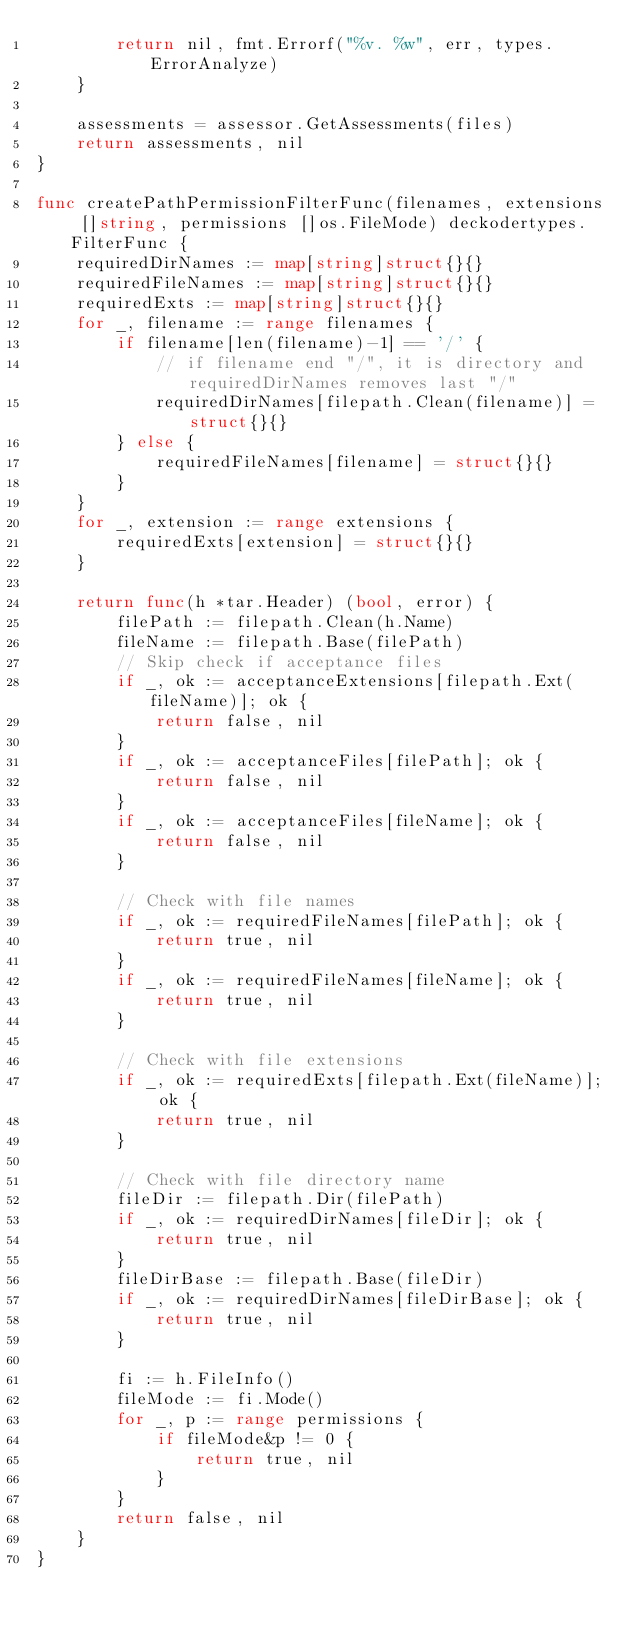Convert code to text. <code><loc_0><loc_0><loc_500><loc_500><_Go_>		return nil, fmt.Errorf("%v. %w", err, types.ErrorAnalyze)
	}

	assessments = assessor.GetAssessments(files)
	return assessments, nil
}

func createPathPermissionFilterFunc(filenames, extensions []string, permissions []os.FileMode) deckodertypes.FilterFunc {
	requiredDirNames := map[string]struct{}{}
	requiredFileNames := map[string]struct{}{}
	requiredExts := map[string]struct{}{}
	for _, filename := range filenames {
		if filename[len(filename)-1] == '/' {
			// if filename end "/", it is directory and requiredDirNames removes last "/"
			requiredDirNames[filepath.Clean(filename)] = struct{}{}
		} else {
			requiredFileNames[filename] = struct{}{}
		}
	}
	for _, extension := range extensions {
		requiredExts[extension] = struct{}{}
	}

	return func(h *tar.Header) (bool, error) {
		filePath := filepath.Clean(h.Name)
		fileName := filepath.Base(filePath)
		// Skip check if acceptance files
		if _, ok := acceptanceExtensions[filepath.Ext(fileName)]; ok {
			return false, nil
		}
		if _, ok := acceptanceFiles[filePath]; ok {
			return false, nil
		}
		if _, ok := acceptanceFiles[fileName]; ok {
			return false, nil
		}

		// Check with file names
		if _, ok := requiredFileNames[filePath]; ok {
			return true, nil
		}
		if _, ok := requiredFileNames[fileName]; ok {
			return true, nil
		}

		// Check with file extensions
		if _, ok := requiredExts[filepath.Ext(fileName)]; ok {
			return true, nil
		}

		// Check with file directory name
		fileDir := filepath.Dir(filePath)
		if _, ok := requiredDirNames[fileDir]; ok {
			return true, nil
		}
		fileDirBase := filepath.Base(fileDir)
		if _, ok := requiredDirNames[fileDirBase]; ok {
			return true, nil
		}

		fi := h.FileInfo()
		fileMode := fi.Mode()
		for _, p := range permissions {
			if fileMode&p != 0 {
				return true, nil
			}
		}
		return false, nil
	}
}
</code> 